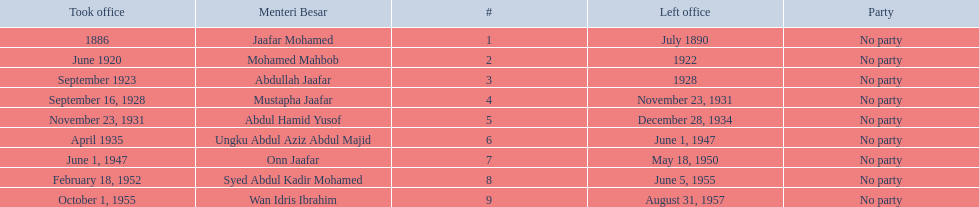Who are all of the menteri besars? Jaafar Mohamed, Mohamed Mahbob, Abdullah Jaafar, Mustapha Jaafar, Abdul Hamid Yusof, Ungku Abdul Aziz Abdul Majid, Onn Jaafar, Syed Abdul Kadir Mohamed, Wan Idris Ibrahim. When did each take office? 1886, June 1920, September 1923, September 16, 1928, November 23, 1931, April 1935, June 1, 1947, February 18, 1952, October 1, 1955. When did they leave? July 1890, 1922, 1928, November 23, 1931, December 28, 1934, June 1, 1947, May 18, 1950, June 5, 1955, August 31, 1957. And which spent the most time in office? Ungku Abdul Aziz Abdul Majid. 